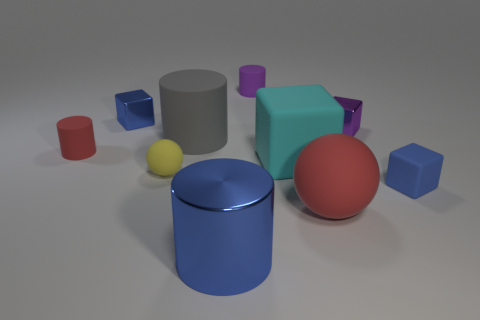Are there more tiny shiny blocks than cylinders?
Keep it short and to the point. No. There is a red cylinder behind the rubber block that is behind the tiny rubber block; are there any small matte cylinders behind it?
Provide a succinct answer. Yes. What number of other objects are the same size as the blue metal cylinder?
Offer a terse response. 3. There is a yellow ball; are there any blue metal blocks to the left of it?
Keep it short and to the point. Yes. There is a big ball; does it have the same color as the tiny metal thing left of the large red sphere?
Ensure brevity in your answer.  No. What is the color of the tiny matte cylinder that is behind the small shiny cube that is on the left side of the red matte object that is in front of the cyan matte cube?
Your answer should be very brief. Purple. Is there a gray object of the same shape as the small red thing?
Ensure brevity in your answer.  Yes. What is the color of the sphere that is the same size as the blue matte block?
Offer a terse response. Yellow. There is a red object that is behind the yellow thing; what is it made of?
Ensure brevity in your answer.  Rubber. Do the red object behind the small yellow thing and the metal object that is in front of the large red matte ball have the same shape?
Your response must be concise. Yes. 